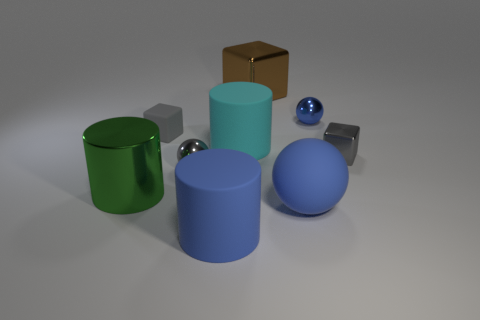How many objects are in the image, and can you describe their shapes? There are six objects in the image: two cylinders, one of them green and the other one sky blue; two spheres, one large and blue, the other small and silver; a brown cube; and a silver cuboid.  If I were to arrange all the objects from the left side to the right side based on their heights, starting with the shortest, which order would they be in? Starting with the shortest, the order from left to right would be: the small silver sphere, the large blue sphere, the silver cuboid, the brown cube, the sky blue cylinder, and finally the green cylinder. 